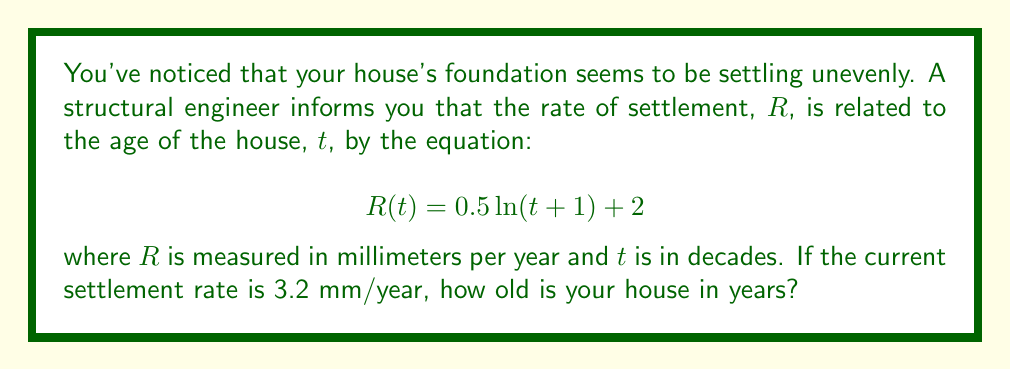What is the answer to this math problem? To solve this inverse problem, we need to follow these steps:

1) We start with the given equation:
   $$R(t) = 0.5 \ln(t + 1) + 2$$

2) We know that the current settlement rate $R$ is 3.2 mm/year. Let's substitute this:
   $$3.2 = 0.5 \ln(t + 1) + 2$$

3) Subtract 2 from both sides:
   $$1.2 = 0.5 \ln(t + 1)$$

4) Multiply both sides by 2:
   $$2.4 = \ln(t + 1)$$

5) Apply the exponential function to both sides:
   $$e^{2.4} = t + 1$$

6) Subtract 1 from both sides:
   $$e^{2.4} - 1 = t$$

7) Calculate this value:
   $$t \approx 10.02$$

8) Remember, $t$ is in decades. To get the age in years, multiply by 10:
   $$\text{Age} = 10t \approx 100.2 \text{ years}$$

9) Since age is typically expressed as a whole number, we round to the nearest year:
   $$\text{Age} \approx 100 \text{ years}$$
Answer: 100 years 